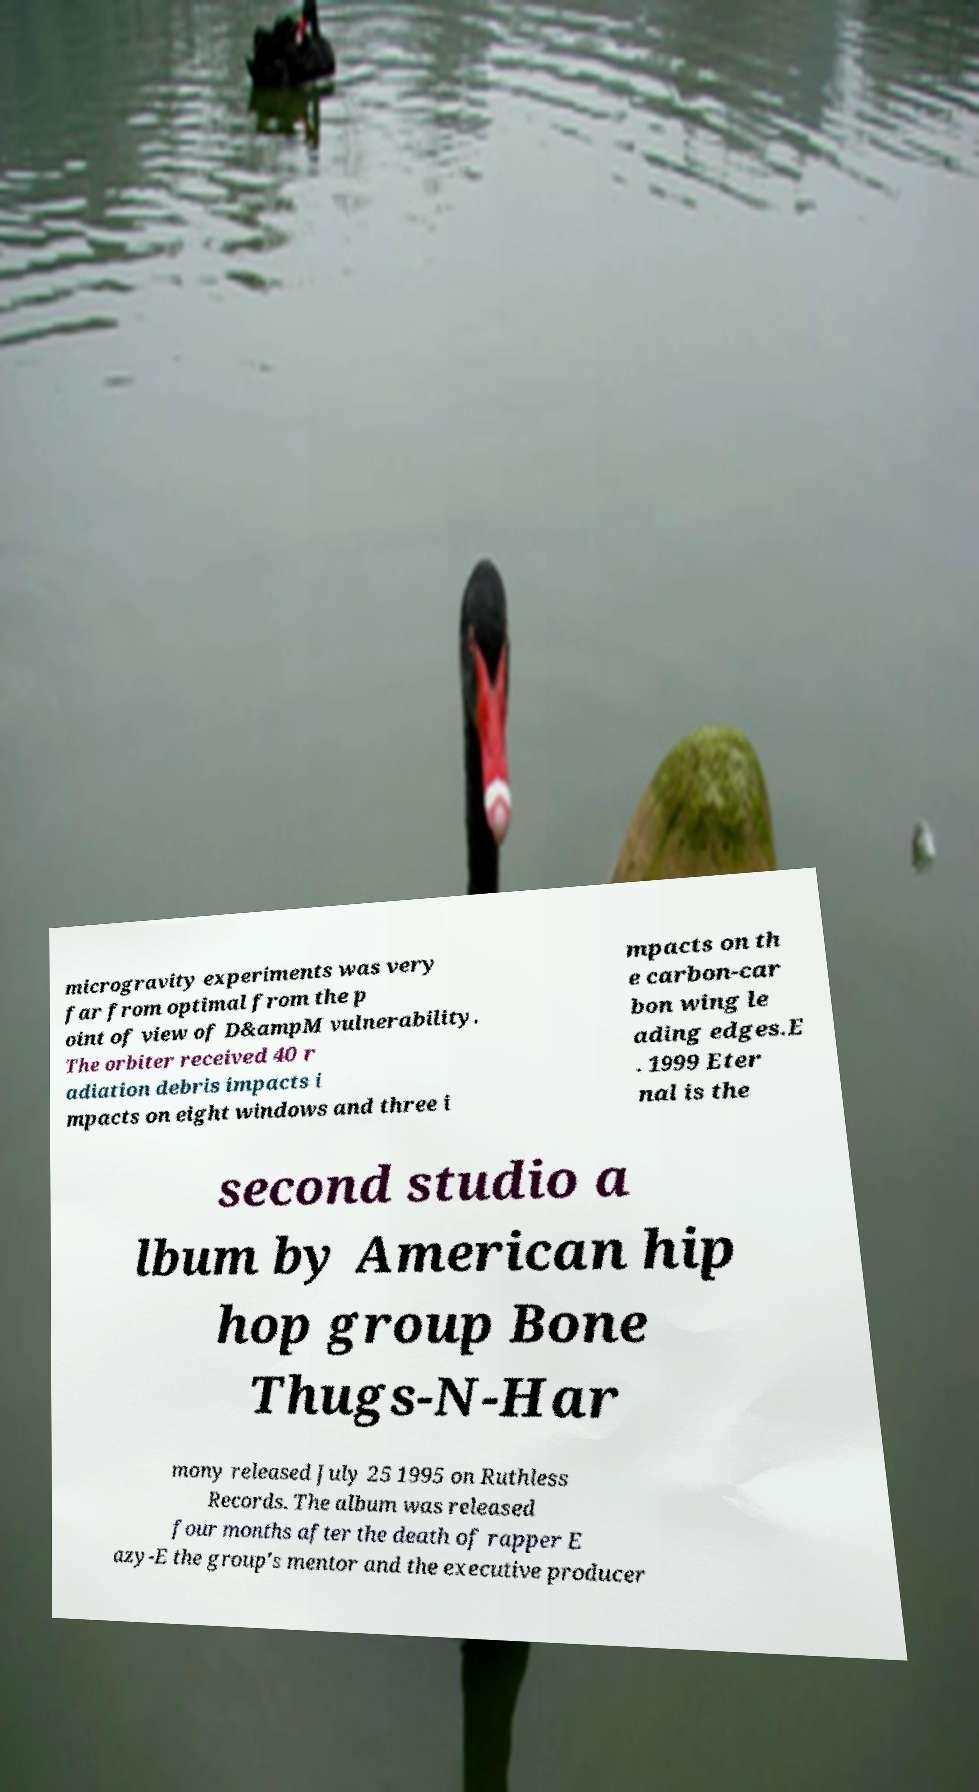Could you extract and type out the text from this image? microgravity experiments was very far from optimal from the p oint of view of D&ampM vulnerability. The orbiter received 40 r adiation debris impacts i mpacts on eight windows and three i mpacts on th e carbon-car bon wing le ading edges.E . 1999 Eter nal is the second studio a lbum by American hip hop group Bone Thugs-N-Har mony released July 25 1995 on Ruthless Records. The album was released four months after the death of rapper E azy-E the group's mentor and the executive producer 